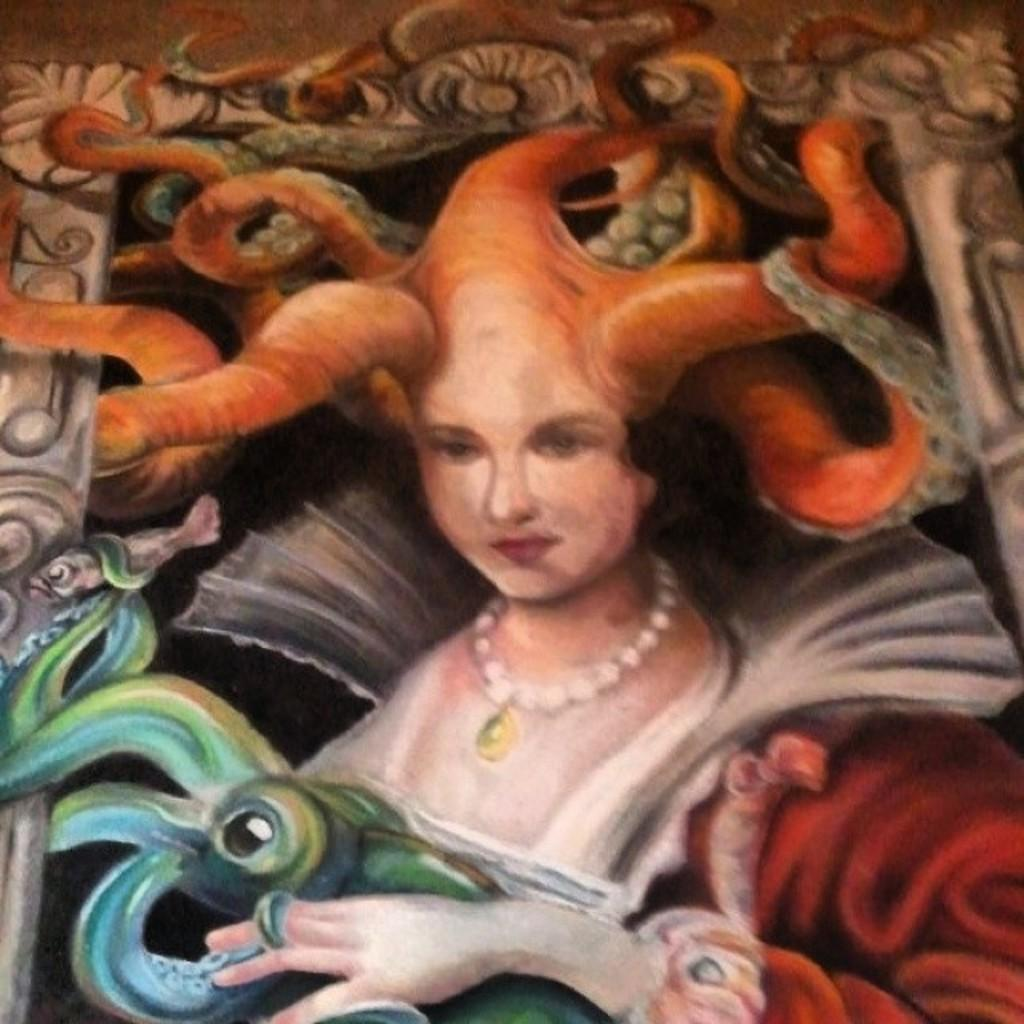What is the main subject of the image? There is a painting in the image. What does the painting depict? The painting depicts a person. What additional features can be seen in the painting? There are designs present in the painting. How many girls are playing in the park in the image? There are no girls or park present in the image; it features a painting of a person with designs. 